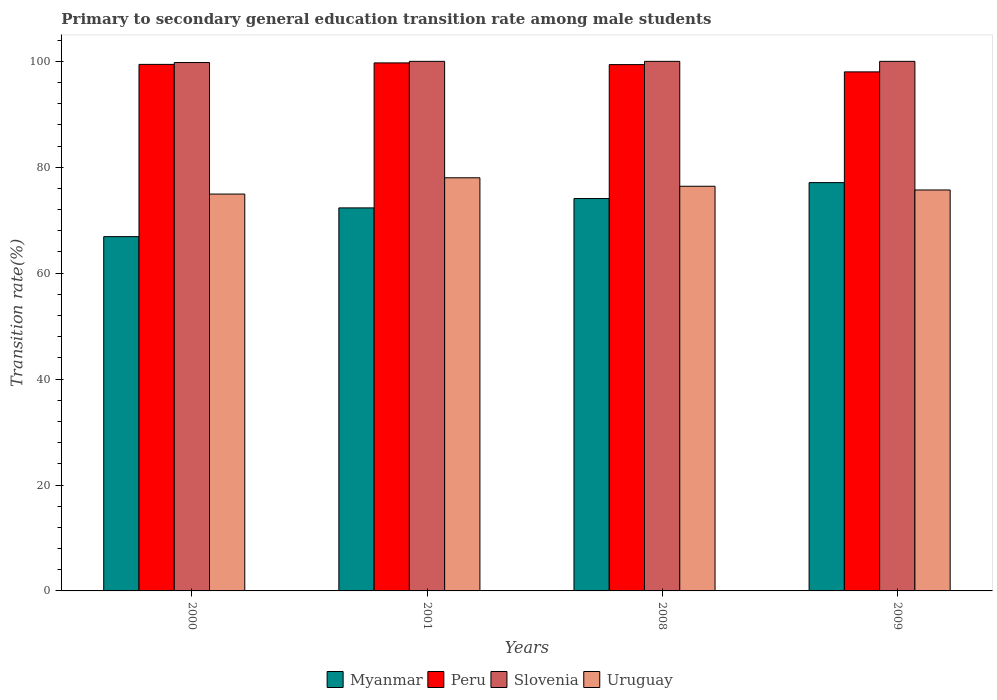How many bars are there on the 4th tick from the right?
Offer a very short reply. 4. In how many cases, is the number of bars for a given year not equal to the number of legend labels?
Provide a succinct answer. 0. Across all years, what is the maximum transition rate in Myanmar?
Give a very brief answer. 77.1. Across all years, what is the minimum transition rate in Myanmar?
Offer a very short reply. 66.9. What is the total transition rate in Uruguay in the graph?
Offer a terse response. 305.08. What is the difference between the transition rate in Myanmar in 2000 and that in 2001?
Keep it short and to the point. -5.43. What is the difference between the transition rate in Myanmar in 2008 and the transition rate in Peru in 2000?
Ensure brevity in your answer.  -25.33. What is the average transition rate in Uruguay per year?
Your answer should be compact. 76.27. In the year 2001, what is the difference between the transition rate in Uruguay and transition rate in Peru?
Make the answer very short. -21.7. In how many years, is the transition rate in Peru greater than 36 %?
Ensure brevity in your answer.  4. What is the ratio of the transition rate in Slovenia in 2000 to that in 2009?
Your response must be concise. 1. Is the difference between the transition rate in Uruguay in 2000 and 2009 greater than the difference between the transition rate in Peru in 2000 and 2009?
Give a very brief answer. No. What is the difference between the highest and the second highest transition rate in Slovenia?
Provide a short and direct response. 0. What is the difference between the highest and the lowest transition rate in Slovenia?
Provide a succinct answer. 0.23. In how many years, is the transition rate in Uruguay greater than the average transition rate in Uruguay taken over all years?
Give a very brief answer. 2. What does the 2nd bar from the left in 2000 represents?
Offer a very short reply. Peru. What does the 1st bar from the right in 2009 represents?
Make the answer very short. Uruguay. Is it the case that in every year, the sum of the transition rate in Peru and transition rate in Slovenia is greater than the transition rate in Myanmar?
Offer a terse response. Yes. How many bars are there?
Offer a terse response. 16. Are all the bars in the graph horizontal?
Make the answer very short. No. How many years are there in the graph?
Offer a very short reply. 4. What is the difference between two consecutive major ticks on the Y-axis?
Your answer should be very brief. 20. Are the values on the major ticks of Y-axis written in scientific E-notation?
Your answer should be compact. No. Does the graph contain any zero values?
Your answer should be very brief. No. Does the graph contain grids?
Provide a short and direct response. No. Where does the legend appear in the graph?
Your answer should be compact. Bottom center. How many legend labels are there?
Offer a terse response. 4. How are the legend labels stacked?
Your response must be concise. Horizontal. What is the title of the graph?
Give a very brief answer. Primary to secondary general education transition rate among male students. Does "Estonia" appear as one of the legend labels in the graph?
Provide a short and direct response. No. What is the label or title of the Y-axis?
Provide a succinct answer. Transition rate(%). What is the Transition rate(%) in Myanmar in 2000?
Make the answer very short. 66.9. What is the Transition rate(%) in Peru in 2000?
Your answer should be very brief. 99.43. What is the Transition rate(%) of Slovenia in 2000?
Your answer should be very brief. 99.77. What is the Transition rate(%) in Uruguay in 2000?
Give a very brief answer. 74.94. What is the Transition rate(%) in Myanmar in 2001?
Keep it short and to the point. 72.33. What is the Transition rate(%) of Peru in 2001?
Keep it short and to the point. 99.71. What is the Transition rate(%) in Uruguay in 2001?
Your answer should be very brief. 78.01. What is the Transition rate(%) of Myanmar in 2008?
Make the answer very short. 74.09. What is the Transition rate(%) of Peru in 2008?
Your response must be concise. 99.39. What is the Transition rate(%) in Slovenia in 2008?
Keep it short and to the point. 100. What is the Transition rate(%) in Uruguay in 2008?
Ensure brevity in your answer.  76.41. What is the Transition rate(%) of Myanmar in 2009?
Offer a terse response. 77.1. What is the Transition rate(%) in Peru in 2009?
Your answer should be compact. 98.01. What is the Transition rate(%) of Slovenia in 2009?
Your answer should be very brief. 100. What is the Transition rate(%) in Uruguay in 2009?
Keep it short and to the point. 75.71. Across all years, what is the maximum Transition rate(%) of Myanmar?
Ensure brevity in your answer.  77.1. Across all years, what is the maximum Transition rate(%) in Peru?
Give a very brief answer. 99.71. Across all years, what is the maximum Transition rate(%) in Slovenia?
Offer a very short reply. 100. Across all years, what is the maximum Transition rate(%) of Uruguay?
Provide a succinct answer. 78.01. Across all years, what is the minimum Transition rate(%) of Myanmar?
Give a very brief answer. 66.9. Across all years, what is the minimum Transition rate(%) in Peru?
Your response must be concise. 98.01. Across all years, what is the minimum Transition rate(%) in Slovenia?
Give a very brief answer. 99.77. Across all years, what is the minimum Transition rate(%) in Uruguay?
Provide a short and direct response. 74.94. What is the total Transition rate(%) of Myanmar in the graph?
Your response must be concise. 290.42. What is the total Transition rate(%) in Peru in the graph?
Your response must be concise. 396.54. What is the total Transition rate(%) in Slovenia in the graph?
Provide a succinct answer. 399.77. What is the total Transition rate(%) of Uruguay in the graph?
Offer a terse response. 305.08. What is the difference between the Transition rate(%) of Myanmar in 2000 and that in 2001?
Make the answer very short. -5.43. What is the difference between the Transition rate(%) of Peru in 2000 and that in 2001?
Your response must be concise. -0.28. What is the difference between the Transition rate(%) in Slovenia in 2000 and that in 2001?
Keep it short and to the point. -0.23. What is the difference between the Transition rate(%) of Uruguay in 2000 and that in 2001?
Your response must be concise. -3.07. What is the difference between the Transition rate(%) in Myanmar in 2000 and that in 2008?
Keep it short and to the point. -7.19. What is the difference between the Transition rate(%) of Peru in 2000 and that in 2008?
Your response must be concise. 0.04. What is the difference between the Transition rate(%) of Slovenia in 2000 and that in 2008?
Your answer should be compact. -0.23. What is the difference between the Transition rate(%) in Uruguay in 2000 and that in 2008?
Provide a succinct answer. -1.47. What is the difference between the Transition rate(%) in Myanmar in 2000 and that in 2009?
Ensure brevity in your answer.  -10.2. What is the difference between the Transition rate(%) in Peru in 2000 and that in 2009?
Ensure brevity in your answer.  1.42. What is the difference between the Transition rate(%) in Slovenia in 2000 and that in 2009?
Make the answer very short. -0.23. What is the difference between the Transition rate(%) of Uruguay in 2000 and that in 2009?
Provide a succinct answer. -0.77. What is the difference between the Transition rate(%) in Myanmar in 2001 and that in 2008?
Provide a short and direct response. -1.77. What is the difference between the Transition rate(%) of Peru in 2001 and that in 2008?
Your answer should be very brief. 0.32. What is the difference between the Transition rate(%) of Uruguay in 2001 and that in 2008?
Provide a succinct answer. 1.6. What is the difference between the Transition rate(%) in Myanmar in 2001 and that in 2009?
Make the answer very short. -4.77. What is the difference between the Transition rate(%) of Peru in 2001 and that in 2009?
Your response must be concise. 1.7. What is the difference between the Transition rate(%) in Uruguay in 2001 and that in 2009?
Offer a very short reply. 2.3. What is the difference between the Transition rate(%) of Myanmar in 2008 and that in 2009?
Give a very brief answer. -3.01. What is the difference between the Transition rate(%) in Peru in 2008 and that in 2009?
Keep it short and to the point. 1.38. What is the difference between the Transition rate(%) of Slovenia in 2008 and that in 2009?
Provide a short and direct response. 0. What is the difference between the Transition rate(%) of Uruguay in 2008 and that in 2009?
Provide a succinct answer. 0.7. What is the difference between the Transition rate(%) in Myanmar in 2000 and the Transition rate(%) in Peru in 2001?
Offer a very short reply. -32.81. What is the difference between the Transition rate(%) in Myanmar in 2000 and the Transition rate(%) in Slovenia in 2001?
Offer a terse response. -33.1. What is the difference between the Transition rate(%) in Myanmar in 2000 and the Transition rate(%) in Uruguay in 2001?
Provide a succinct answer. -11.11. What is the difference between the Transition rate(%) of Peru in 2000 and the Transition rate(%) of Slovenia in 2001?
Your answer should be very brief. -0.57. What is the difference between the Transition rate(%) of Peru in 2000 and the Transition rate(%) of Uruguay in 2001?
Make the answer very short. 21.42. What is the difference between the Transition rate(%) of Slovenia in 2000 and the Transition rate(%) of Uruguay in 2001?
Offer a terse response. 21.76. What is the difference between the Transition rate(%) in Myanmar in 2000 and the Transition rate(%) in Peru in 2008?
Give a very brief answer. -32.49. What is the difference between the Transition rate(%) in Myanmar in 2000 and the Transition rate(%) in Slovenia in 2008?
Your answer should be compact. -33.1. What is the difference between the Transition rate(%) of Myanmar in 2000 and the Transition rate(%) of Uruguay in 2008?
Your response must be concise. -9.51. What is the difference between the Transition rate(%) of Peru in 2000 and the Transition rate(%) of Slovenia in 2008?
Offer a terse response. -0.57. What is the difference between the Transition rate(%) of Peru in 2000 and the Transition rate(%) of Uruguay in 2008?
Your answer should be compact. 23.01. What is the difference between the Transition rate(%) in Slovenia in 2000 and the Transition rate(%) in Uruguay in 2008?
Ensure brevity in your answer.  23.36. What is the difference between the Transition rate(%) of Myanmar in 2000 and the Transition rate(%) of Peru in 2009?
Offer a very short reply. -31.11. What is the difference between the Transition rate(%) of Myanmar in 2000 and the Transition rate(%) of Slovenia in 2009?
Keep it short and to the point. -33.1. What is the difference between the Transition rate(%) of Myanmar in 2000 and the Transition rate(%) of Uruguay in 2009?
Keep it short and to the point. -8.81. What is the difference between the Transition rate(%) of Peru in 2000 and the Transition rate(%) of Slovenia in 2009?
Keep it short and to the point. -0.57. What is the difference between the Transition rate(%) of Peru in 2000 and the Transition rate(%) of Uruguay in 2009?
Your answer should be very brief. 23.71. What is the difference between the Transition rate(%) of Slovenia in 2000 and the Transition rate(%) of Uruguay in 2009?
Your answer should be very brief. 24.06. What is the difference between the Transition rate(%) of Myanmar in 2001 and the Transition rate(%) of Peru in 2008?
Provide a short and direct response. -27.06. What is the difference between the Transition rate(%) in Myanmar in 2001 and the Transition rate(%) in Slovenia in 2008?
Make the answer very short. -27.67. What is the difference between the Transition rate(%) of Myanmar in 2001 and the Transition rate(%) of Uruguay in 2008?
Offer a terse response. -4.09. What is the difference between the Transition rate(%) of Peru in 2001 and the Transition rate(%) of Slovenia in 2008?
Your response must be concise. -0.29. What is the difference between the Transition rate(%) in Peru in 2001 and the Transition rate(%) in Uruguay in 2008?
Offer a terse response. 23.29. What is the difference between the Transition rate(%) in Slovenia in 2001 and the Transition rate(%) in Uruguay in 2008?
Keep it short and to the point. 23.59. What is the difference between the Transition rate(%) of Myanmar in 2001 and the Transition rate(%) of Peru in 2009?
Your answer should be very brief. -25.68. What is the difference between the Transition rate(%) in Myanmar in 2001 and the Transition rate(%) in Slovenia in 2009?
Provide a succinct answer. -27.67. What is the difference between the Transition rate(%) in Myanmar in 2001 and the Transition rate(%) in Uruguay in 2009?
Your answer should be very brief. -3.39. What is the difference between the Transition rate(%) of Peru in 2001 and the Transition rate(%) of Slovenia in 2009?
Offer a terse response. -0.29. What is the difference between the Transition rate(%) of Peru in 2001 and the Transition rate(%) of Uruguay in 2009?
Give a very brief answer. 23.99. What is the difference between the Transition rate(%) in Slovenia in 2001 and the Transition rate(%) in Uruguay in 2009?
Your answer should be compact. 24.29. What is the difference between the Transition rate(%) of Myanmar in 2008 and the Transition rate(%) of Peru in 2009?
Provide a succinct answer. -23.92. What is the difference between the Transition rate(%) in Myanmar in 2008 and the Transition rate(%) in Slovenia in 2009?
Make the answer very short. -25.91. What is the difference between the Transition rate(%) in Myanmar in 2008 and the Transition rate(%) in Uruguay in 2009?
Your answer should be very brief. -1.62. What is the difference between the Transition rate(%) of Peru in 2008 and the Transition rate(%) of Slovenia in 2009?
Keep it short and to the point. -0.61. What is the difference between the Transition rate(%) of Peru in 2008 and the Transition rate(%) of Uruguay in 2009?
Your response must be concise. 23.67. What is the difference between the Transition rate(%) in Slovenia in 2008 and the Transition rate(%) in Uruguay in 2009?
Provide a succinct answer. 24.29. What is the average Transition rate(%) of Myanmar per year?
Your response must be concise. 72.61. What is the average Transition rate(%) of Peru per year?
Your answer should be compact. 99.13. What is the average Transition rate(%) of Slovenia per year?
Make the answer very short. 99.94. What is the average Transition rate(%) of Uruguay per year?
Your response must be concise. 76.27. In the year 2000, what is the difference between the Transition rate(%) in Myanmar and Transition rate(%) in Peru?
Your response must be concise. -32.53. In the year 2000, what is the difference between the Transition rate(%) in Myanmar and Transition rate(%) in Slovenia?
Ensure brevity in your answer.  -32.87. In the year 2000, what is the difference between the Transition rate(%) in Myanmar and Transition rate(%) in Uruguay?
Keep it short and to the point. -8.04. In the year 2000, what is the difference between the Transition rate(%) of Peru and Transition rate(%) of Slovenia?
Your answer should be compact. -0.35. In the year 2000, what is the difference between the Transition rate(%) in Peru and Transition rate(%) in Uruguay?
Offer a very short reply. 24.49. In the year 2000, what is the difference between the Transition rate(%) in Slovenia and Transition rate(%) in Uruguay?
Make the answer very short. 24.83. In the year 2001, what is the difference between the Transition rate(%) in Myanmar and Transition rate(%) in Peru?
Provide a short and direct response. -27.38. In the year 2001, what is the difference between the Transition rate(%) in Myanmar and Transition rate(%) in Slovenia?
Provide a succinct answer. -27.67. In the year 2001, what is the difference between the Transition rate(%) in Myanmar and Transition rate(%) in Uruguay?
Your answer should be very brief. -5.68. In the year 2001, what is the difference between the Transition rate(%) in Peru and Transition rate(%) in Slovenia?
Make the answer very short. -0.29. In the year 2001, what is the difference between the Transition rate(%) in Peru and Transition rate(%) in Uruguay?
Your response must be concise. 21.7. In the year 2001, what is the difference between the Transition rate(%) in Slovenia and Transition rate(%) in Uruguay?
Your answer should be compact. 21.99. In the year 2008, what is the difference between the Transition rate(%) in Myanmar and Transition rate(%) in Peru?
Offer a terse response. -25.29. In the year 2008, what is the difference between the Transition rate(%) of Myanmar and Transition rate(%) of Slovenia?
Offer a very short reply. -25.91. In the year 2008, what is the difference between the Transition rate(%) of Myanmar and Transition rate(%) of Uruguay?
Your answer should be very brief. -2.32. In the year 2008, what is the difference between the Transition rate(%) of Peru and Transition rate(%) of Slovenia?
Your answer should be compact. -0.61. In the year 2008, what is the difference between the Transition rate(%) in Peru and Transition rate(%) in Uruguay?
Keep it short and to the point. 22.97. In the year 2008, what is the difference between the Transition rate(%) in Slovenia and Transition rate(%) in Uruguay?
Your answer should be compact. 23.59. In the year 2009, what is the difference between the Transition rate(%) of Myanmar and Transition rate(%) of Peru?
Your response must be concise. -20.91. In the year 2009, what is the difference between the Transition rate(%) of Myanmar and Transition rate(%) of Slovenia?
Provide a short and direct response. -22.9. In the year 2009, what is the difference between the Transition rate(%) of Myanmar and Transition rate(%) of Uruguay?
Your answer should be very brief. 1.39. In the year 2009, what is the difference between the Transition rate(%) of Peru and Transition rate(%) of Slovenia?
Provide a succinct answer. -1.99. In the year 2009, what is the difference between the Transition rate(%) in Peru and Transition rate(%) in Uruguay?
Offer a very short reply. 22.3. In the year 2009, what is the difference between the Transition rate(%) of Slovenia and Transition rate(%) of Uruguay?
Give a very brief answer. 24.29. What is the ratio of the Transition rate(%) in Myanmar in 2000 to that in 2001?
Your response must be concise. 0.93. What is the ratio of the Transition rate(%) in Peru in 2000 to that in 2001?
Your response must be concise. 1. What is the ratio of the Transition rate(%) of Slovenia in 2000 to that in 2001?
Give a very brief answer. 1. What is the ratio of the Transition rate(%) in Uruguay in 2000 to that in 2001?
Make the answer very short. 0.96. What is the ratio of the Transition rate(%) of Myanmar in 2000 to that in 2008?
Your response must be concise. 0.9. What is the ratio of the Transition rate(%) in Uruguay in 2000 to that in 2008?
Provide a short and direct response. 0.98. What is the ratio of the Transition rate(%) in Myanmar in 2000 to that in 2009?
Your response must be concise. 0.87. What is the ratio of the Transition rate(%) of Peru in 2000 to that in 2009?
Offer a terse response. 1.01. What is the ratio of the Transition rate(%) in Myanmar in 2001 to that in 2008?
Keep it short and to the point. 0.98. What is the ratio of the Transition rate(%) of Uruguay in 2001 to that in 2008?
Provide a short and direct response. 1.02. What is the ratio of the Transition rate(%) of Myanmar in 2001 to that in 2009?
Provide a short and direct response. 0.94. What is the ratio of the Transition rate(%) in Peru in 2001 to that in 2009?
Keep it short and to the point. 1.02. What is the ratio of the Transition rate(%) of Uruguay in 2001 to that in 2009?
Make the answer very short. 1.03. What is the ratio of the Transition rate(%) of Peru in 2008 to that in 2009?
Offer a very short reply. 1.01. What is the ratio of the Transition rate(%) of Slovenia in 2008 to that in 2009?
Offer a terse response. 1. What is the ratio of the Transition rate(%) of Uruguay in 2008 to that in 2009?
Offer a very short reply. 1.01. What is the difference between the highest and the second highest Transition rate(%) of Myanmar?
Provide a succinct answer. 3.01. What is the difference between the highest and the second highest Transition rate(%) of Peru?
Ensure brevity in your answer.  0.28. What is the difference between the highest and the second highest Transition rate(%) in Uruguay?
Offer a terse response. 1.6. What is the difference between the highest and the lowest Transition rate(%) of Peru?
Ensure brevity in your answer.  1.7. What is the difference between the highest and the lowest Transition rate(%) of Slovenia?
Provide a short and direct response. 0.23. What is the difference between the highest and the lowest Transition rate(%) in Uruguay?
Your response must be concise. 3.07. 